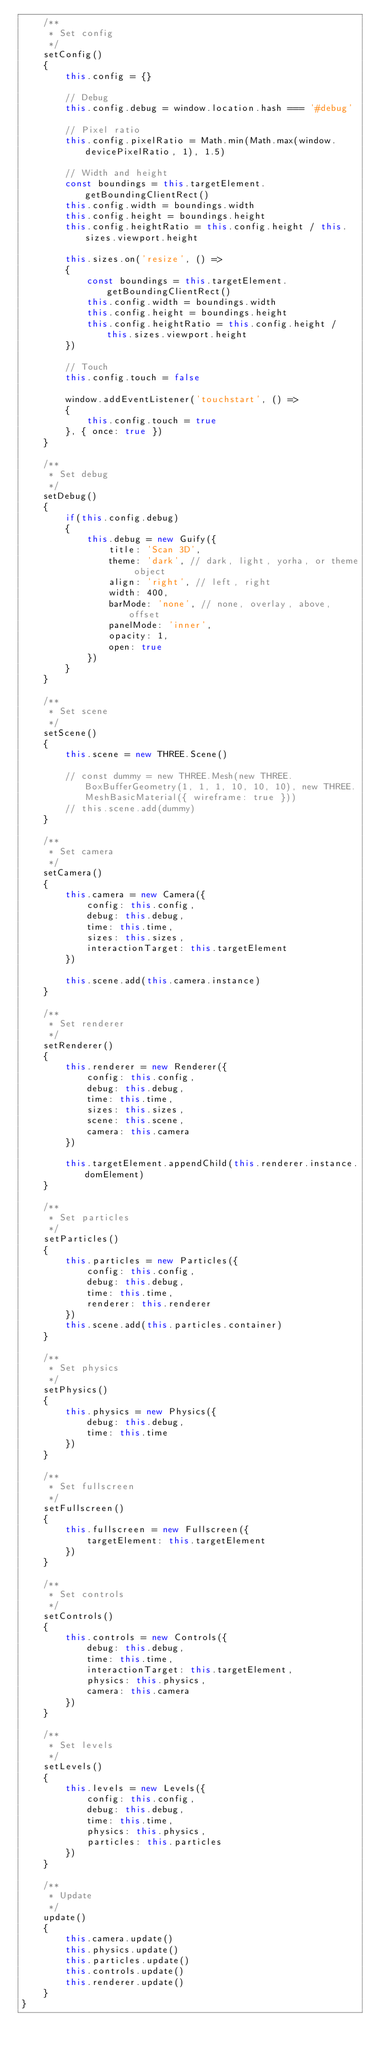<code> <loc_0><loc_0><loc_500><loc_500><_JavaScript_>    /**
     * Set config
     */
    setConfig()
    {
        this.config = {}

        // Debug
        this.config.debug = window.location.hash === '#debug'

        // Pixel ratio
        this.config.pixelRatio = Math.min(Math.max(window.devicePixelRatio, 1), 1.5)

        // Width and height
        const boundings = this.targetElement.getBoundingClientRect()
        this.config.width = boundings.width
        this.config.height = boundings.height
        this.config.heightRatio = this.config.height / this.sizes.viewport.height

        this.sizes.on('resize', () =>
        {
            const boundings = this.targetElement.getBoundingClientRect()
            this.config.width = boundings.width
            this.config.height = boundings.height
            this.config.heightRatio = this.config.height / this.sizes.viewport.height
        })

        // Touch
        this.config.touch = false

        window.addEventListener('touchstart', () =>
        {
            this.config.touch = true
        }, { once: true })
    }

    /**
     * Set debug
     */
    setDebug()
    {
        if(this.config.debug)
        {
            this.debug = new Guify({
                title: 'Scan 3D',
                theme: 'dark', // dark, light, yorha, or theme object
                align: 'right', // left, right
                width: 400,
                barMode: 'none', // none, overlay, above, offset
                panelMode: 'inner',
                opacity: 1,
                open: true
            })
        }
    }

    /**
     * Set scene
     */
    setScene()
    {
        this.scene = new THREE.Scene()

        // const dummy = new THREE.Mesh(new THREE.BoxBufferGeometry(1, 1, 1, 10, 10, 10), new THREE.MeshBasicMaterial({ wireframe: true }))
        // this.scene.add(dummy)
    }

    /**
     * Set camera
     */
    setCamera()
    {
        this.camera = new Camera({
            config: this.config,
            debug: this.debug,
            time: this.time,
            sizes: this.sizes,
            interactionTarget: this.targetElement
        })

        this.scene.add(this.camera.instance)
    }

    /**
     * Set renderer
     */
    setRenderer()
    {
        this.renderer = new Renderer({
            config: this.config,
            debug: this.debug,
            time: this.time,
            sizes: this.sizes,
            scene: this.scene,
            camera: this.camera
        })

        this.targetElement.appendChild(this.renderer.instance.domElement)
    }

    /**
     * Set particles
     */
    setParticles()
    {
        this.particles = new Particles({
            config: this.config,
            debug: this.debug,
            time: this.time,
            renderer: this.renderer
        })
        this.scene.add(this.particles.container)
    }

    /**
     * Set physics
     */
    setPhysics()
    {
        this.physics = new Physics({
            debug: this.debug,
            time: this.time
        })
    }

    /**
     * Set fullscreen
     */
    setFullscreen()
    {
        this.fullscreen = new Fullscreen({
            targetElement: this.targetElement
        })
    }

    /**
     * Set controls
     */
    setControls()
    {
        this.controls = new Controls({
            debug: this.debug,
            time: this.time,
            interactionTarget: this.targetElement,
            physics: this.physics,
            camera: this.camera
        })
    }

    /**
     * Set levels
     */
    setLevels()
    {
        this.levels = new Levels({
            config: this.config,
            debug: this.debug,
            time: this.time,
            physics: this.physics,
            particles: this.particles
        })
    }

    /**
     * Update
     */
    update()
    {
        this.camera.update()
        this.physics.update()
        this.particles.update()
        this.controls.update()
        this.renderer.update()
    }
}
</code> 